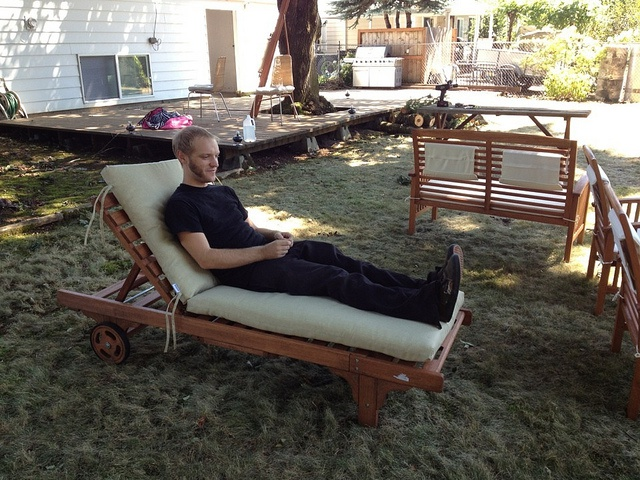Describe the objects in this image and their specific colors. I can see people in white, black, gray, and maroon tones, bench in white, maroon, and gray tones, bench in white, maroon, darkgray, and gray tones, chair in white, maroon, ivory, black, and darkgray tones, and people in white, black, brown, and gray tones in this image. 